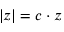Convert formula to latex. <formula><loc_0><loc_0><loc_500><loc_500>| z | = c \cdot z</formula> 